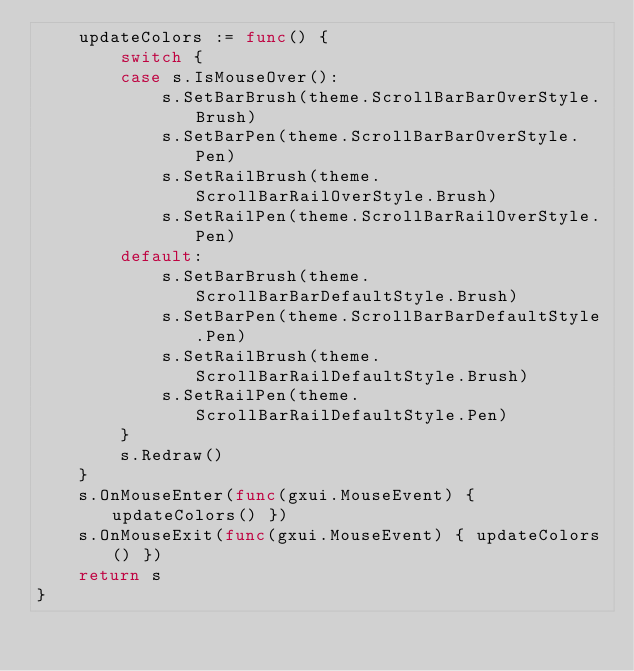<code> <loc_0><loc_0><loc_500><loc_500><_Go_>	updateColors := func() {
		switch {
		case s.IsMouseOver():
			s.SetBarBrush(theme.ScrollBarBarOverStyle.Brush)
			s.SetBarPen(theme.ScrollBarBarOverStyle.Pen)
			s.SetRailBrush(theme.ScrollBarRailOverStyle.Brush)
			s.SetRailPen(theme.ScrollBarRailOverStyle.Pen)
		default:
			s.SetBarBrush(theme.ScrollBarBarDefaultStyle.Brush)
			s.SetBarPen(theme.ScrollBarBarDefaultStyle.Pen)
			s.SetRailBrush(theme.ScrollBarRailDefaultStyle.Brush)
			s.SetRailPen(theme.ScrollBarRailDefaultStyle.Pen)
		}
		s.Redraw()
	}
	s.OnMouseEnter(func(gxui.MouseEvent) { updateColors() })
	s.OnMouseExit(func(gxui.MouseEvent) { updateColors() })
	return s
}
</code> 